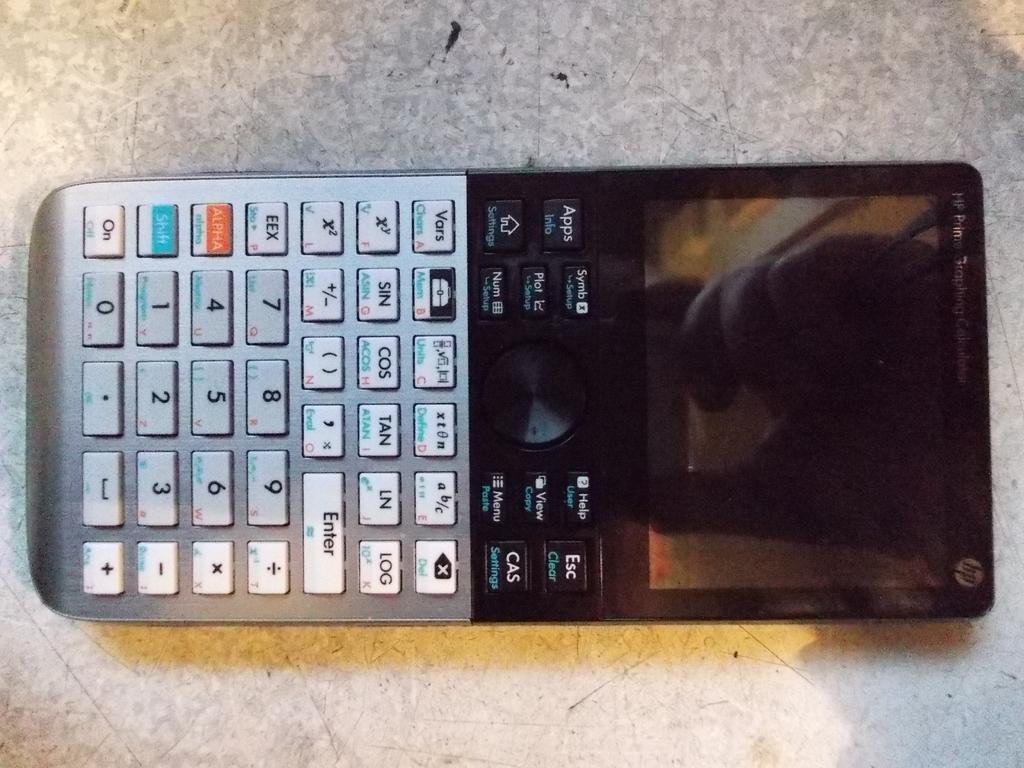<image>
Present a compact description of the photo's key features. An HP digital display calculator is laying on its back with a reflection showing on its blank screen. 